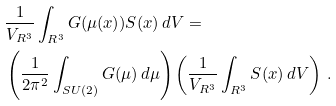<formula> <loc_0><loc_0><loc_500><loc_500>& \frac { 1 } { V _ { R ^ { 3 } } } \int _ { R ^ { 3 } } G ( \mu ( x ) ) S ( x ) \, d V = \\ & \left ( \frac { 1 } { 2 \pi ^ { 2 } } \int _ { S U ( 2 ) } G ( \mu ) \, d \mu \right ) \left ( \frac { 1 } { V _ { R ^ { 3 } } } \int _ { R ^ { 3 } } S ( x ) \, d V \right ) \, .</formula> 